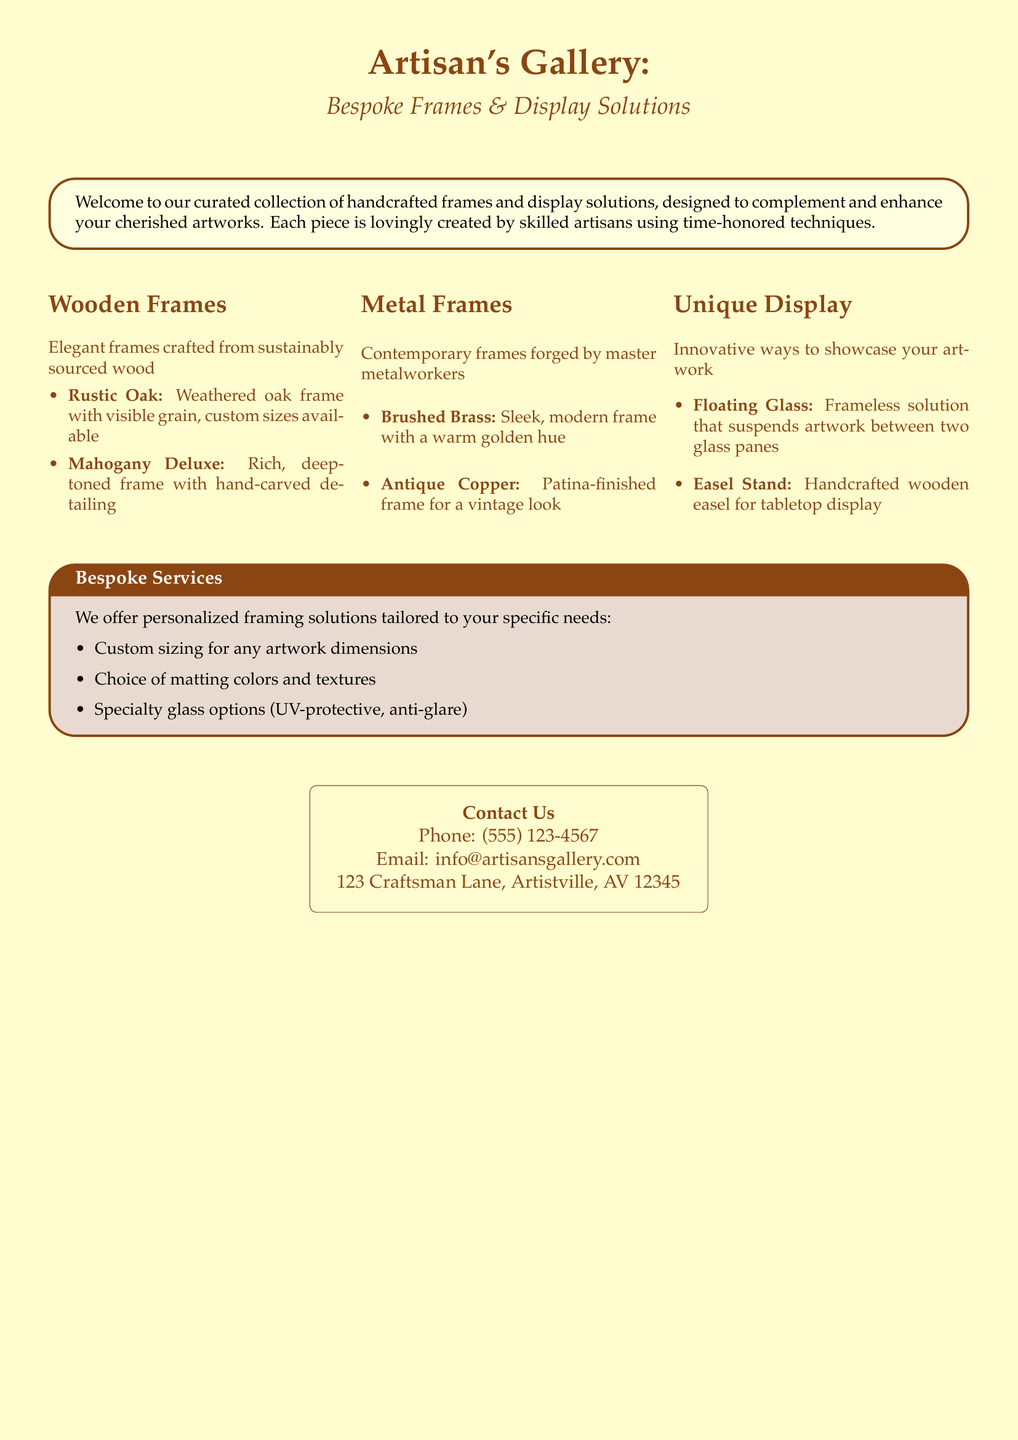what types of frames are available? The document lists three types of frames: Wooden Frames, Metal Frames, and Unique Display solutions.
Answer: Wooden Frames, Metal Frames, Unique Display what is the phone number for contact? The contact section provides a phone number for inquiries.
Answer: (555) 123-4567 which wood type is mentioned for the rustic frame? The document specifies the type of wood used for the rustic frame.
Answer: Oak what unique display option allows frameless artwork? The document describes an innovative option for displaying artwork without a frame.
Answer: Floating Glass what type of service is offered for sizing? The catalog mentions a specific service related to the dimensions of artwork.
Answer: Custom sizing how many metal frame styles are listed? The document provides specific styles of metal frames under one section.
Answer: 2 what is the email address for inquiries? The contact information includes an email for further correspondence.
Answer: info@artisansgallery.com what is the main color palette of the document? The document features a color scheme that blends with the theme of craftsmanship.
Answer: Rustic and Parchment what type of matting choices are offered? Customization options include a specific feature related to artwork presentation.
Answer: Colors and textures 